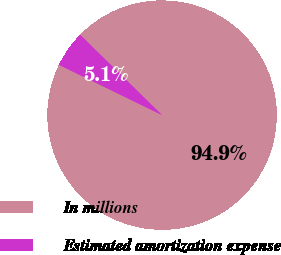Convert chart to OTSL. <chart><loc_0><loc_0><loc_500><loc_500><pie_chart><fcel>In millions<fcel>Estimated amortization expense<nl><fcel>94.87%<fcel>5.13%<nl></chart> 